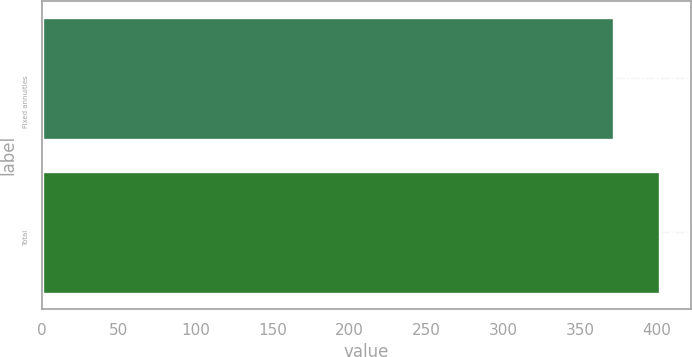Convert chart to OTSL. <chart><loc_0><loc_0><loc_500><loc_500><bar_chart><fcel>Fixed annuities<fcel>Total<nl><fcel>372<fcel>402<nl></chart> 